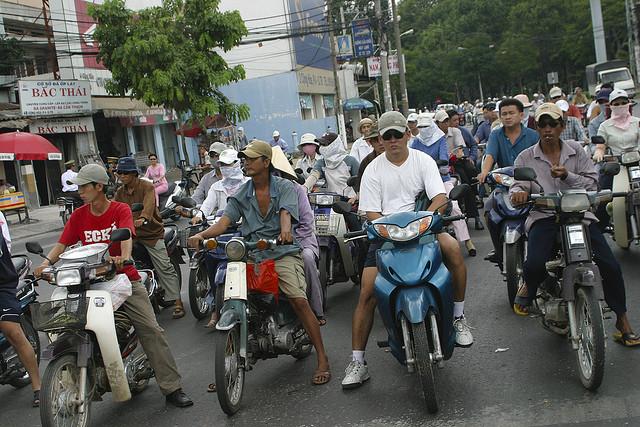What country is this located?
Give a very brief answer. Vietnam. What is nearly everyone wearing on their head?
Be succinct. Hat. Are they having a street race?
Be succinct. Yes. 